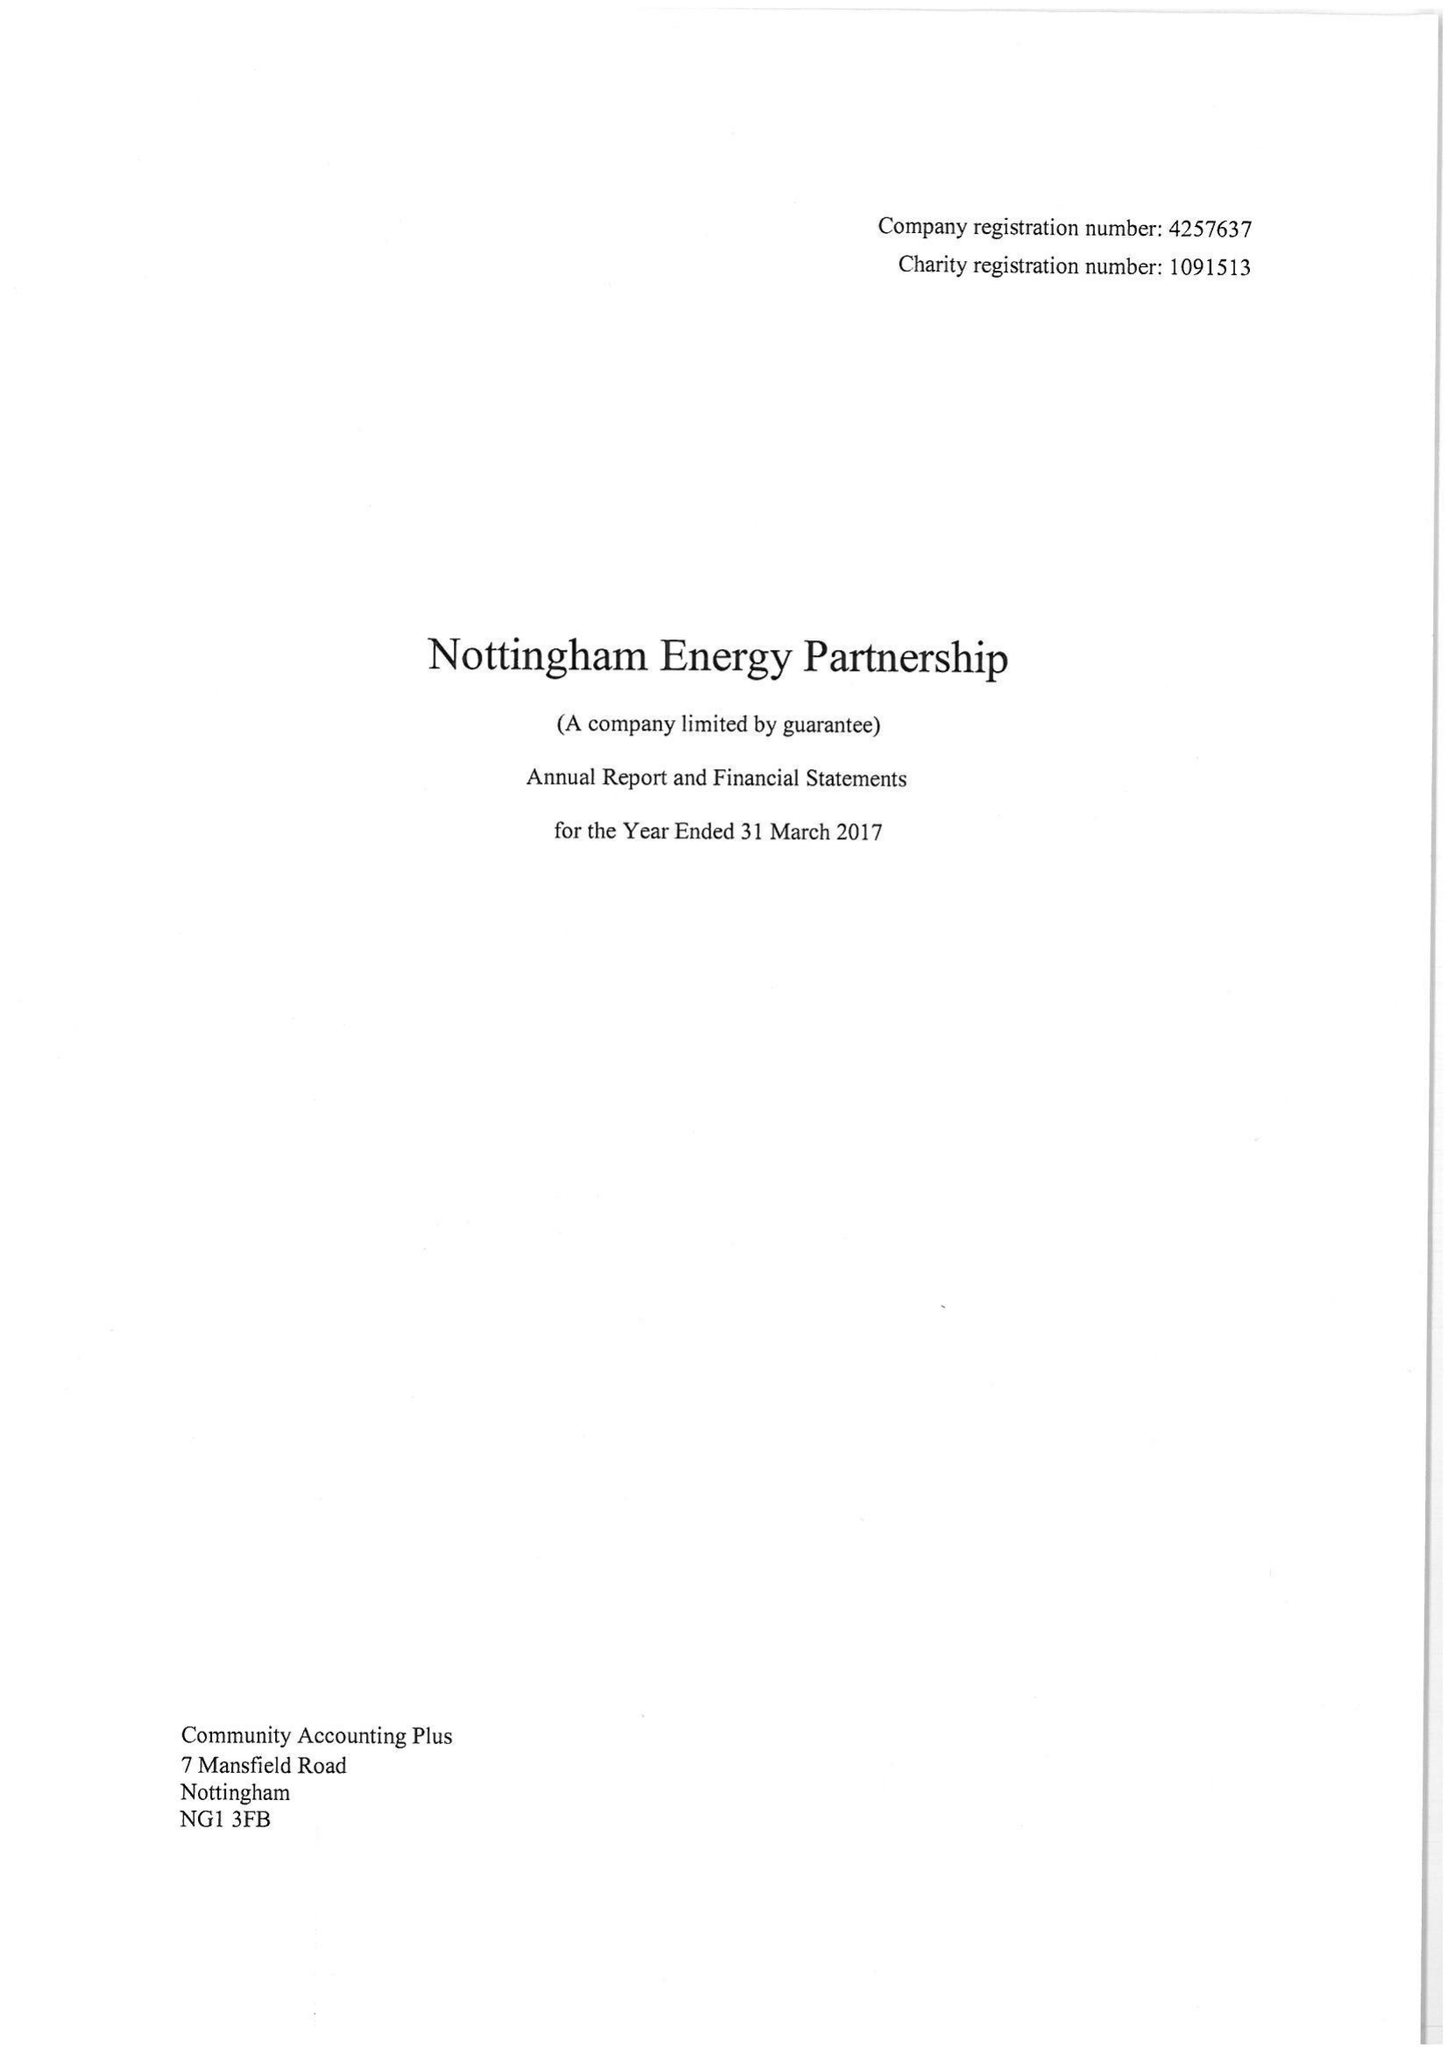What is the value for the report_date?
Answer the question using a single word or phrase. 2017-03-31 